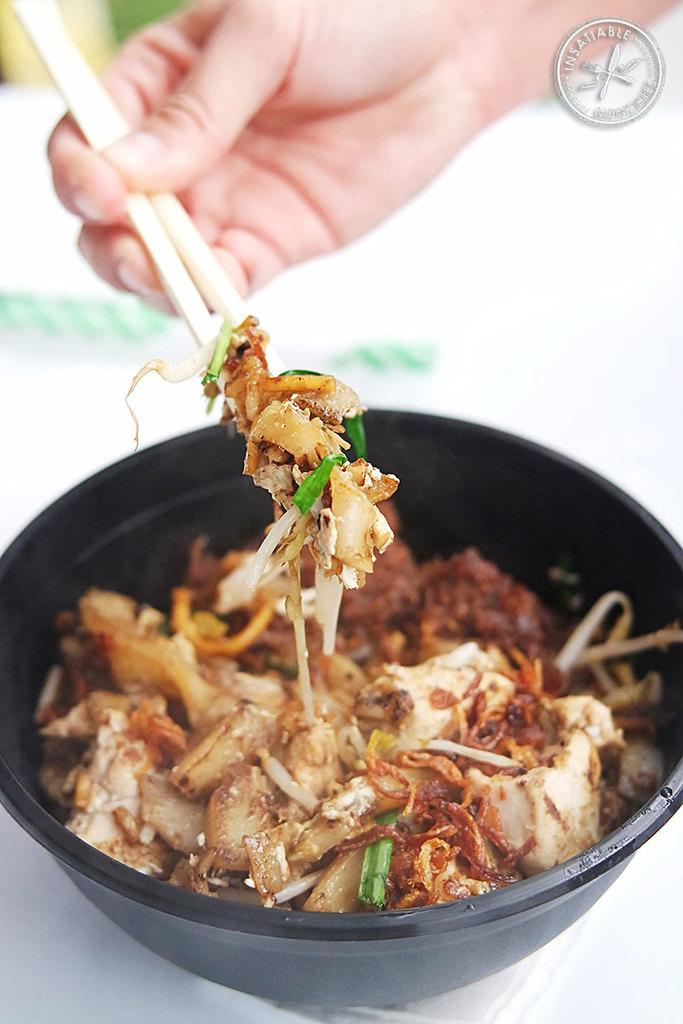What is the person in the image doing? The person in the image is holding chopsticks in their hand. What is the person holding with their chopsticks? The person is holding a bowl with food in the image. How is the bowl being held? The bowl is being held by the person. What can be seen in the top right corner of the image? There is an emblem in the top right corner of the image. What type of machine is being used to prepare the dinner in the image? There is no machine visible in the image, and the dinner is not being prepared; it is already in the bowl being held by the person. 